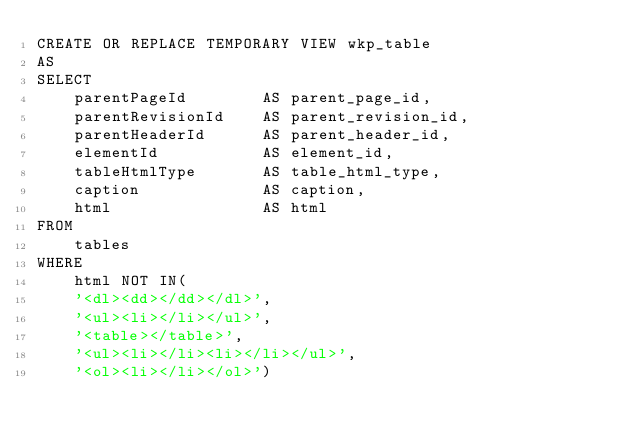Convert code to text. <code><loc_0><loc_0><loc_500><loc_500><_SQL_>CREATE OR REPLACE TEMPORARY VIEW wkp_table
AS
SELECT 
    parentPageId        AS parent_page_id,	
    parentRevisionId    AS parent_revision_id,	
    parentHeaderId      AS parent_header_id,
    elementId           AS element_id,	
    tableHtmlType       AS table_html_type,	
    caption             AS caption,
    html                AS html
FROM 
    tables
WHERE
    html NOT IN(
    '<dl><dd></dd></dl>',
    '<ul><li></li></ul>',
    '<table></table>',
    '<ul><li></li><li></li></ul>',
    '<ol><li></li></ol>')</code> 